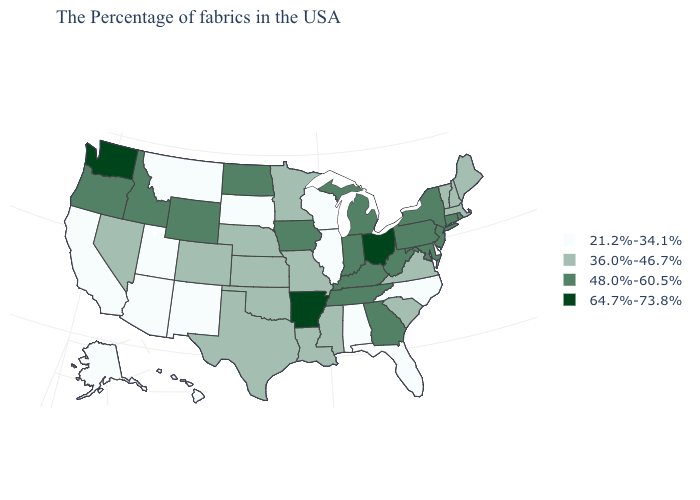Which states have the lowest value in the USA?
Answer briefly. Delaware, North Carolina, Florida, Alabama, Wisconsin, Illinois, South Dakota, New Mexico, Utah, Montana, Arizona, California, Alaska, Hawaii. Among the states that border Iowa , does Wisconsin have the lowest value?
Give a very brief answer. Yes. What is the highest value in the West ?
Short answer required. 64.7%-73.8%. Among the states that border Texas , does Oklahoma have the lowest value?
Concise answer only. No. What is the lowest value in the South?
Short answer required. 21.2%-34.1%. Is the legend a continuous bar?
Keep it brief. No. Does Nevada have the lowest value in the USA?
Be succinct. No. Which states have the highest value in the USA?
Be succinct. Ohio, Arkansas, Washington. What is the value of Washington?
Quick response, please. 64.7%-73.8%. What is the highest value in the MidWest ?
Write a very short answer. 64.7%-73.8%. What is the value of Kansas?
Keep it brief. 36.0%-46.7%. Name the states that have a value in the range 36.0%-46.7%?
Be succinct. Maine, Massachusetts, New Hampshire, Vermont, Virginia, South Carolina, Mississippi, Louisiana, Missouri, Minnesota, Kansas, Nebraska, Oklahoma, Texas, Colorado, Nevada. Name the states that have a value in the range 64.7%-73.8%?
Be succinct. Ohio, Arkansas, Washington. Which states have the lowest value in the USA?
Answer briefly. Delaware, North Carolina, Florida, Alabama, Wisconsin, Illinois, South Dakota, New Mexico, Utah, Montana, Arizona, California, Alaska, Hawaii. Among the states that border Pennsylvania , does Delaware have the lowest value?
Quick response, please. Yes. 